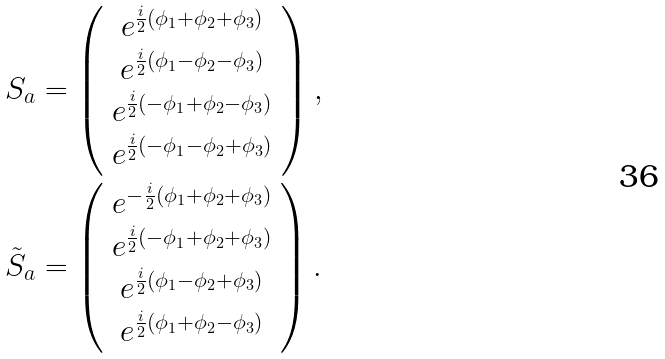<formula> <loc_0><loc_0><loc_500><loc_500>& S _ { a } = \left ( \begin{array} { c } e ^ { \frac { i } { 2 } ( \phi _ { 1 } + \phi _ { 2 } + \phi _ { 3 } ) } \\ e ^ { \frac { i } { 2 } ( \phi _ { 1 } - \phi _ { 2 } - \phi _ { 3 } ) } \\ e ^ { \frac { i } { 2 } ( - \phi _ { 1 } + \phi _ { 2 } - \phi _ { 3 } ) } \\ e ^ { \frac { i } { 2 } ( - \phi _ { 1 } - \phi _ { 2 } + \phi _ { 3 } ) } \end{array} \right ) , \\ & \tilde { S } _ { a } = \left ( \begin{array} { c } e ^ { - \frac { i } { 2 } ( \phi _ { 1 } + \phi _ { 2 } + \phi _ { 3 } ) } \\ e ^ { \frac { i } { 2 } ( - \phi _ { 1 } + \phi _ { 2 } + \phi _ { 3 } ) } \\ e ^ { \frac { i } { 2 } ( \phi _ { 1 } - \phi _ { 2 } + \phi _ { 3 } ) } \\ e ^ { \frac { i } { 2 } ( \phi _ { 1 } + \phi _ { 2 } - \phi _ { 3 } ) } \end{array} \right ) .</formula> 